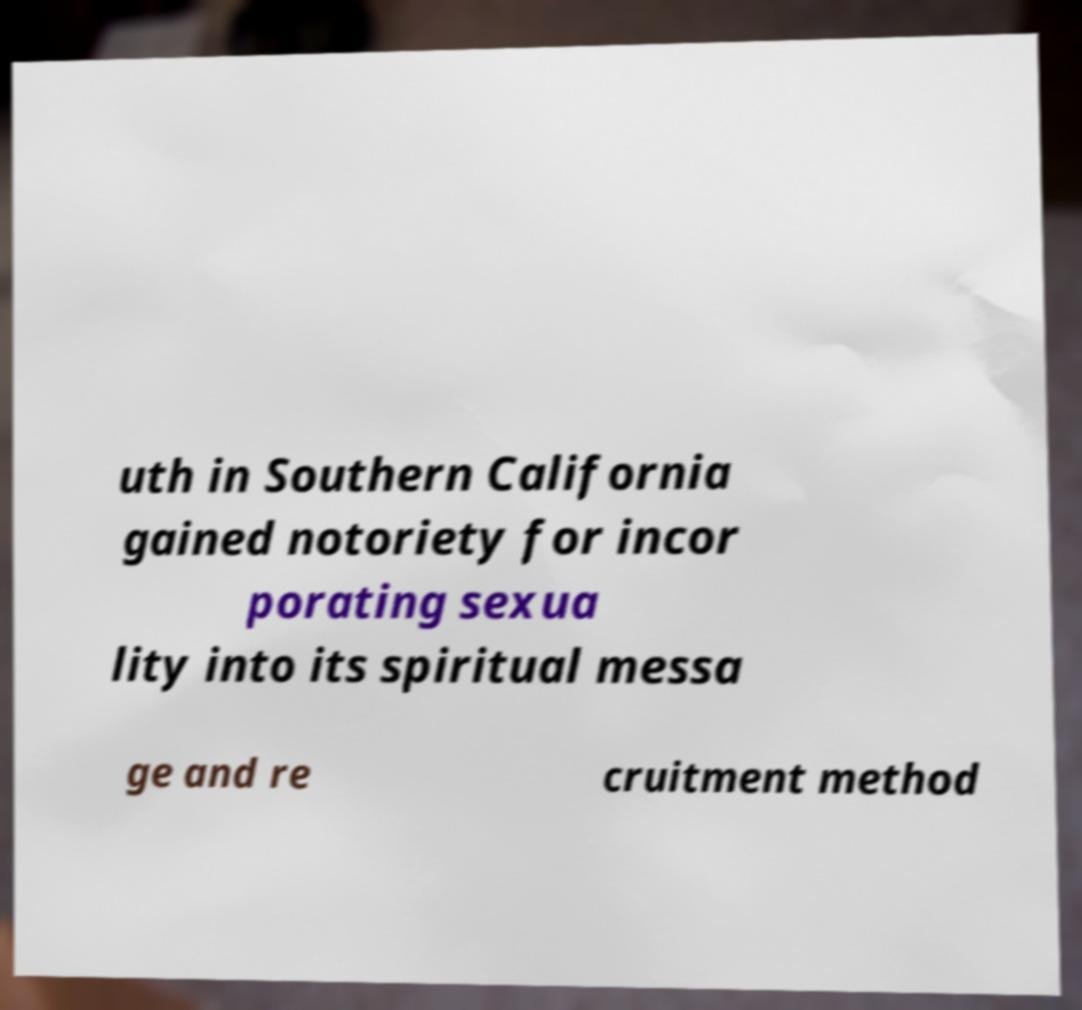Can you read and provide the text displayed in the image?This photo seems to have some interesting text. Can you extract and type it out for me? uth in Southern California gained notoriety for incor porating sexua lity into its spiritual messa ge and re cruitment method 